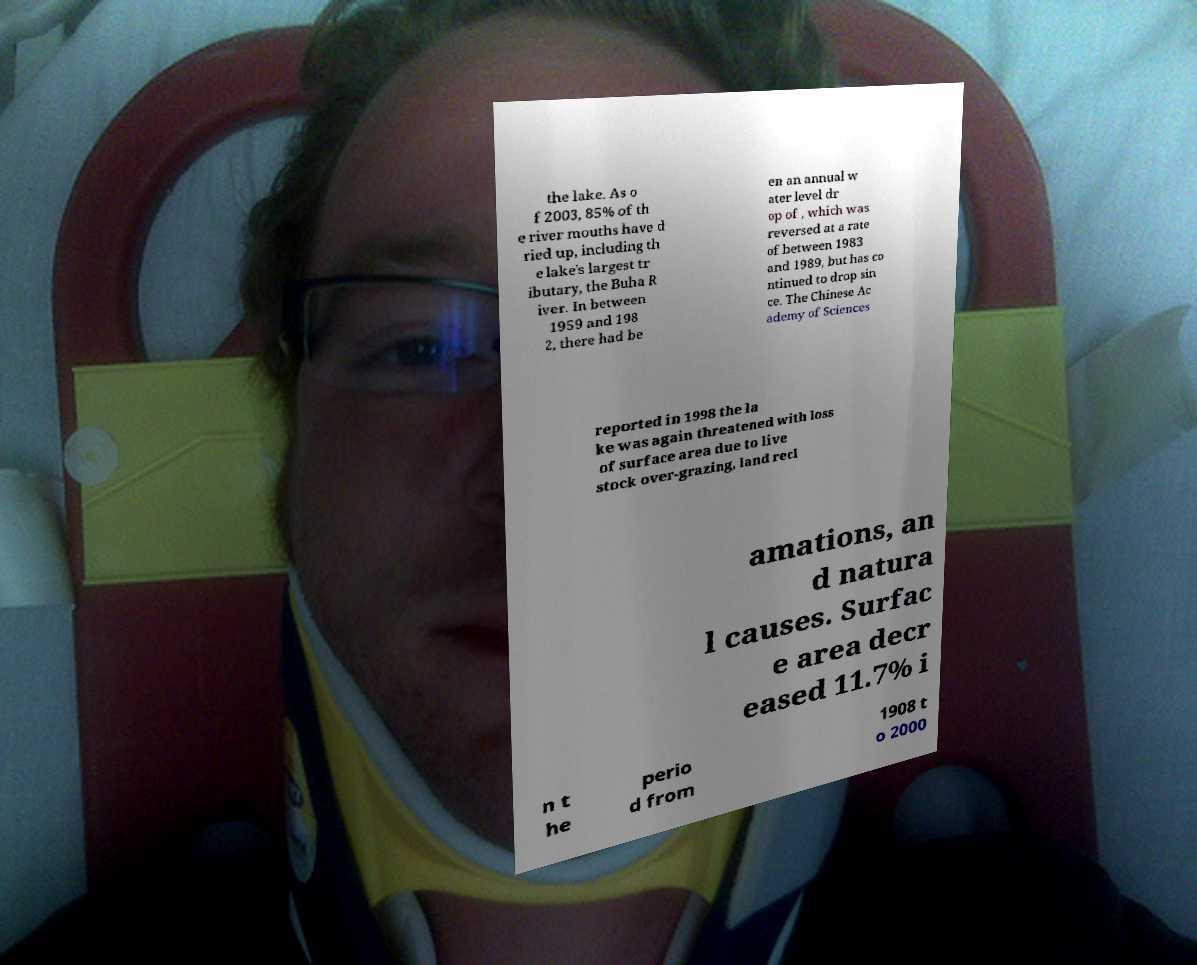There's text embedded in this image that I need extracted. Can you transcribe it verbatim? the lake. As o f 2003, 85% of th e river mouths have d ried up, including th e lake's largest tr ibutary, the Buha R iver. In between 1959 and 198 2, there had be en an annual w ater level dr op of , which was reversed at a rate of between 1983 and 1989, but has co ntinued to drop sin ce. The Chinese Ac ademy of Sciences reported in 1998 the la ke was again threatened with loss of surface area due to live stock over-grazing, land recl amations, an d natura l causes. Surfac e area decr eased 11.7% i n t he perio d from 1908 t o 2000 